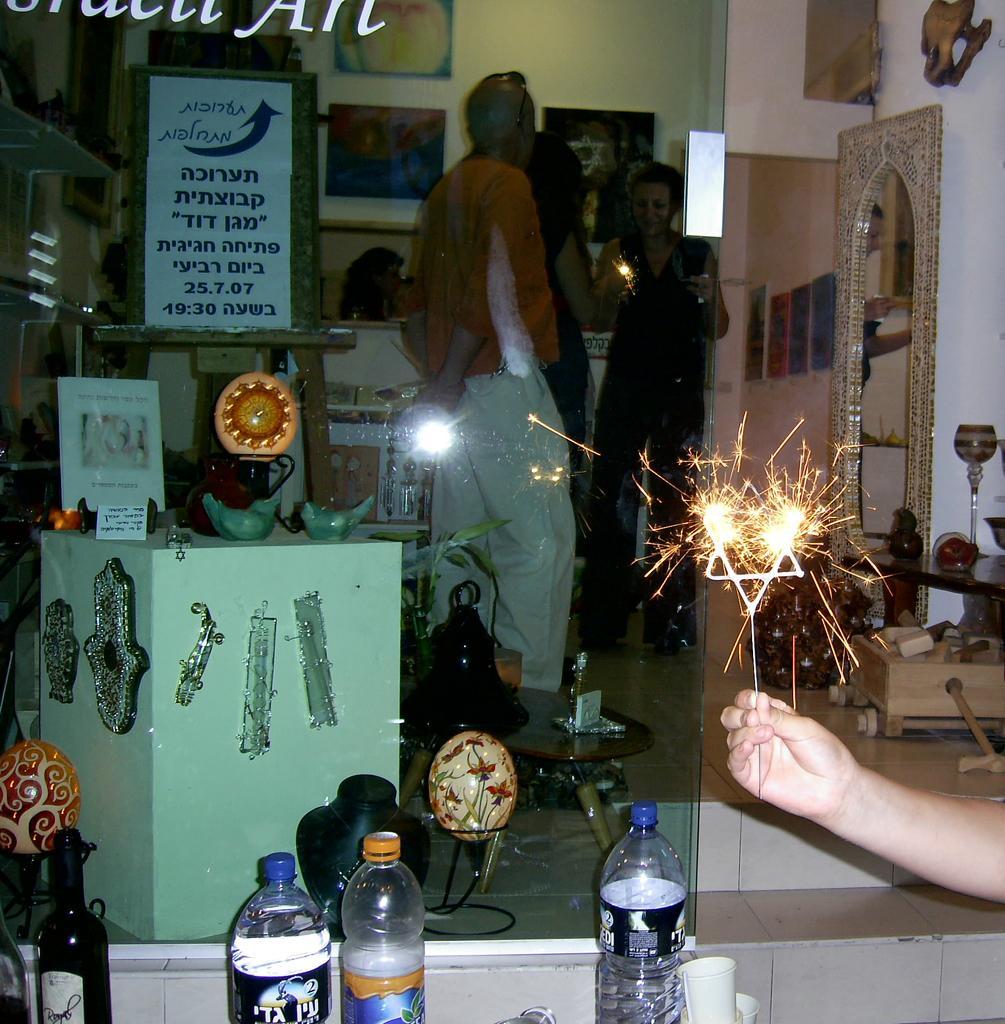Describe this image in one or two sentences. In the center we can see the three persons were standing. In the bottom we can see some water bottles,in the left side we can see some stand. And in the right side we can see some human hand. And back of him we can see mirrors and few objects. 